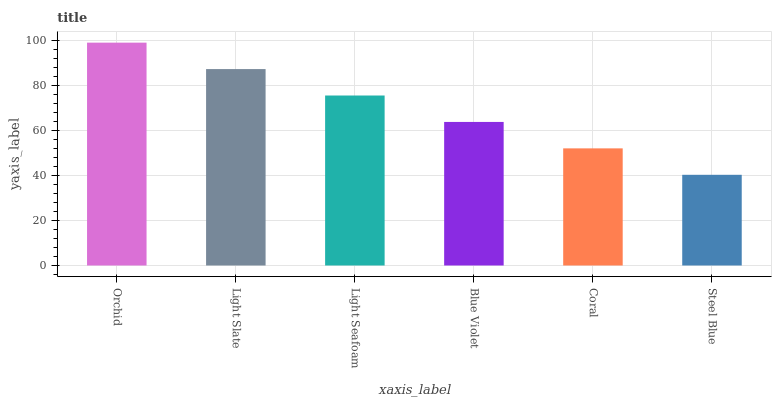Is Steel Blue the minimum?
Answer yes or no. Yes. Is Orchid the maximum?
Answer yes or no. Yes. Is Light Slate the minimum?
Answer yes or no. No. Is Light Slate the maximum?
Answer yes or no. No. Is Orchid greater than Light Slate?
Answer yes or no. Yes. Is Light Slate less than Orchid?
Answer yes or no. Yes. Is Light Slate greater than Orchid?
Answer yes or no. No. Is Orchid less than Light Slate?
Answer yes or no. No. Is Light Seafoam the high median?
Answer yes or no. Yes. Is Blue Violet the low median?
Answer yes or no. Yes. Is Orchid the high median?
Answer yes or no. No. Is Light Seafoam the low median?
Answer yes or no. No. 